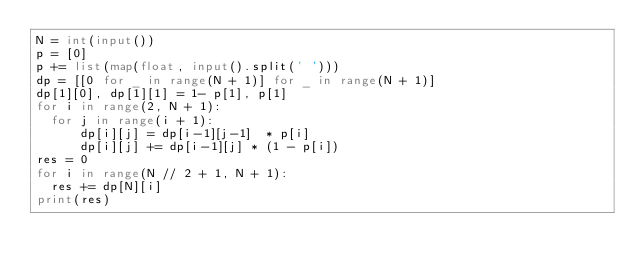Convert code to text. <code><loc_0><loc_0><loc_500><loc_500><_Python_>N = int(input())
p = [0]
p += list(map(float, input().split(' ')))
dp = [[0 for _ in range(N + 1)] for _ in range(N + 1)]
dp[1][0], dp[1][1] = 1- p[1], p[1]
for i in range(2, N + 1):
  for j in range(i + 1):
      dp[i][j] = dp[i-1][j-1]  * p[i]
      dp[i][j] += dp[i-1][j] * (1 - p[i])
res = 0
for i in range(N // 2 + 1, N + 1):
  res += dp[N][i]
print(res)</code> 